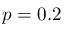<formula> <loc_0><loc_0><loc_500><loc_500>p = 0 . 2</formula> 